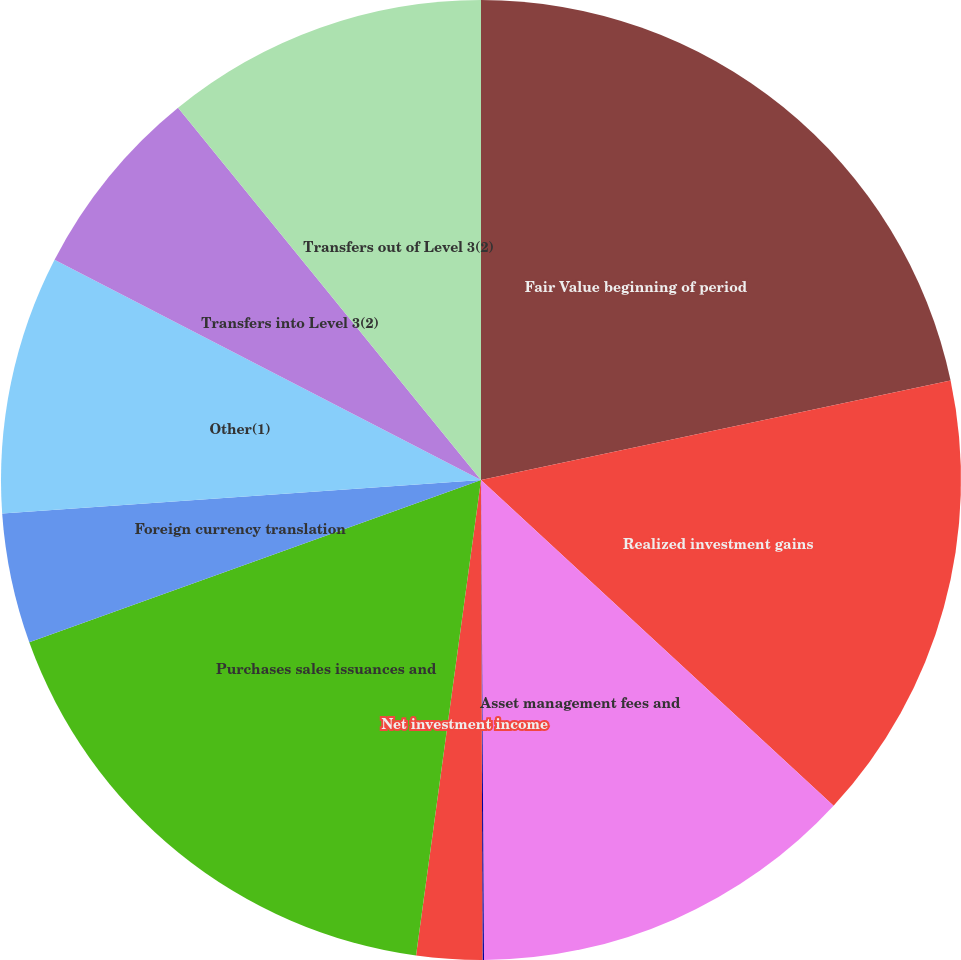<chart> <loc_0><loc_0><loc_500><loc_500><pie_chart><fcel>Fair Value beginning of period<fcel>Realized investment gains<fcel>Asset management fees and<fcel>Included in other<fcel>Net investment income<fcel>Purchases sales issuances and<fcel>Foreign currency translation<fcel>Other(1)<fcel>Transfers into Level 3(2)<fcel>Transfers out of Level 3(2)<nl><fcel>21.68%<fcel>15.19%<fcel>13.03%<fcel>0.05%<fcel>2.21%<fcel>17.35%<fcel>4.38%<fcel>8.7%<fcel>6.54%<fcel>10.87%<nl></chart> 